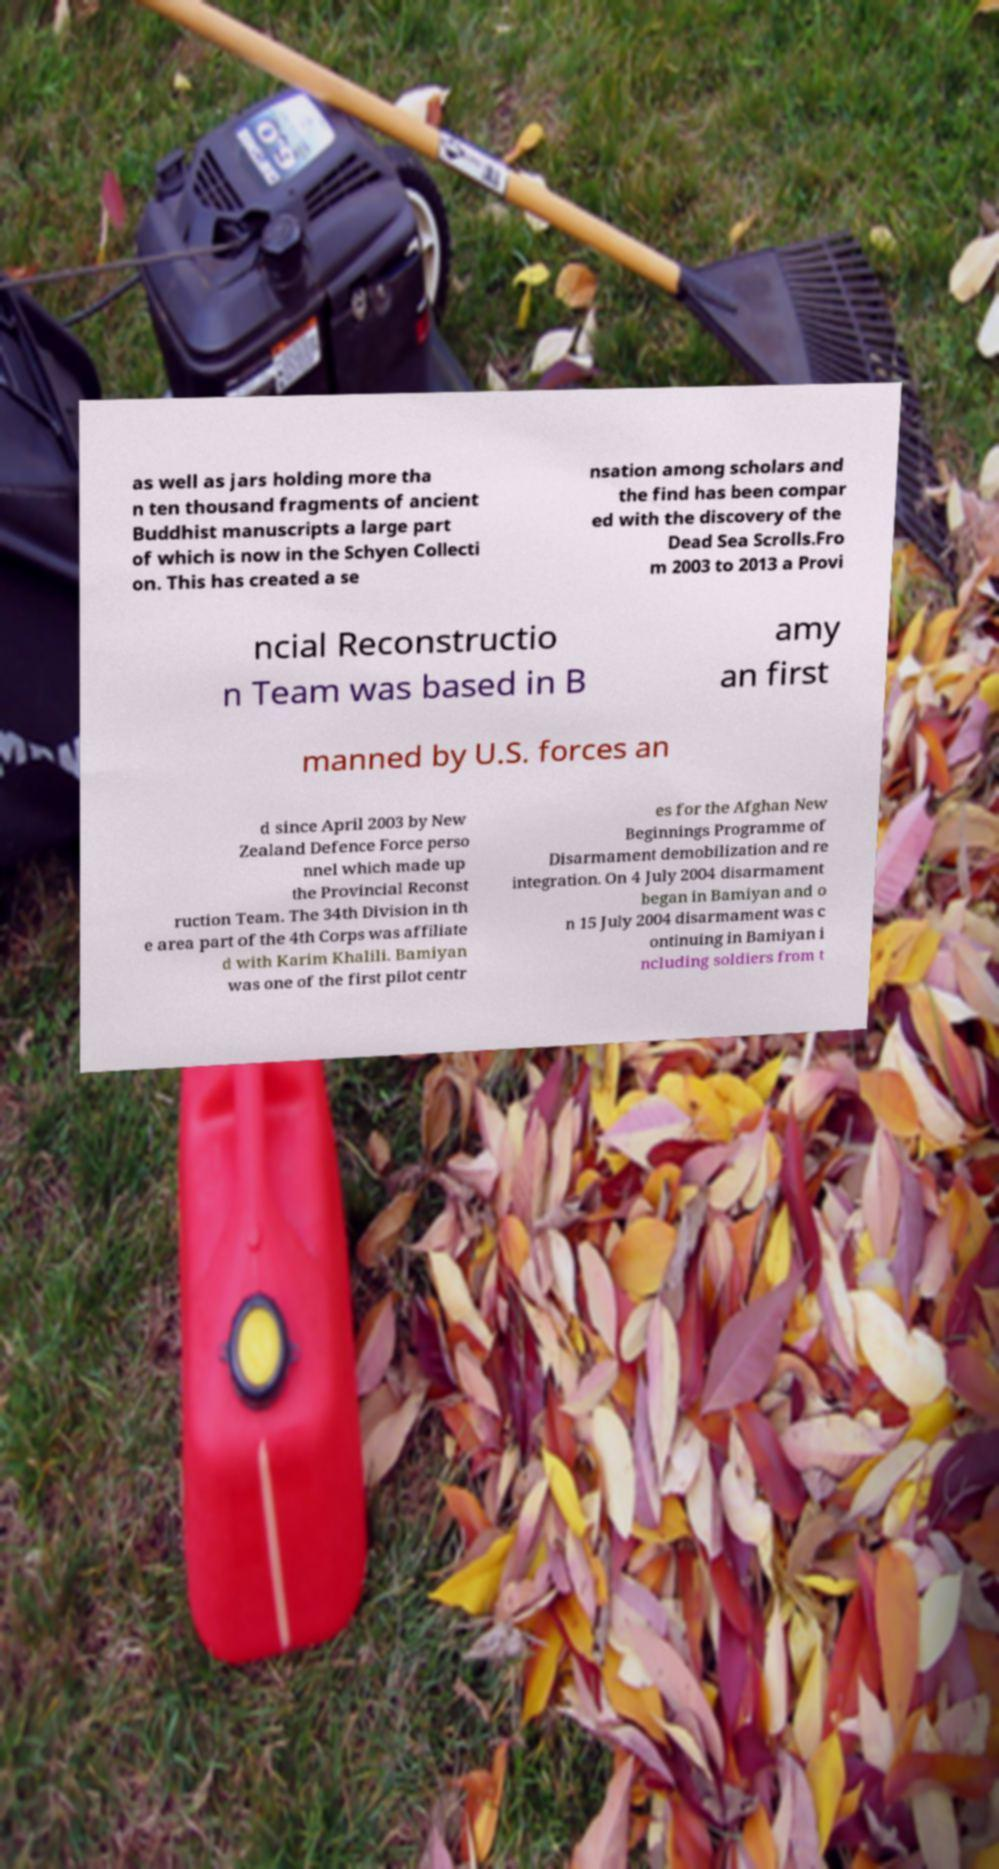Can you accurately transcribe the text from the provided image for me? as well as jars holding more tha n ten thousand fragments of ancient Buddhist manuscripts a large part of which is now in the Schyen Collecti on. This has created a se nsation among scholars and the find has been compar ed with the discovery of the Dead Sea Scrolls.Fro m 2003 to 2013 a Provi ncial Reconstructio n Team was based in B amy an first manned by U.S. forces an d since April 2003 by New Zealand Defence Force perso nnel which made up the Provincial Reconst ruction Team. The 34th Division in th e area part of the 4th Corps was affiliate d with Karim Khalili. Bamiyan was one of the first pilot centr es for the Afghan New Beginnings Programme of Disarmament demobilization and re integration. On 4 July 2004 disarmament began in Bamiyan and o n 15 July 2004 disarmament was c ontinuing in Bamiyan i ncluding soldiers from t 